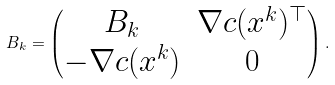Convert formula to latex. <formula><loc_0><loc_0><loc_500><loc_500>B _ { k } = \begin{pmatrix} B _ { k } & \nabla c ( x ^ { k } ) ^ { \top } \\ - \nabla c ( x ^ { k } ) & 0 \end{pmatrix} .</formula> 